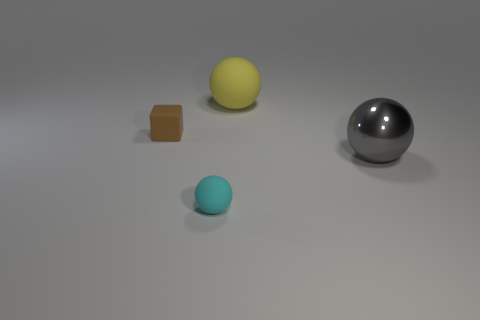There is a cyan ball that is the same size as the brown rubber object; what is it made of?
Your answer should be compact. Rubber. There is a matte object that is in front of the tiny thing left of the tiny rubber ball; what color is it?
Offer a terse response. Cyan. What number of spheres are right of the small rubber ball?
Your answer should be very brief. 2. What is the color of the small matte ball?
Offer a terse response. Cyan. How many small objects are red metallic blocks or brown cubes?
Offer a very short reply. 1. There is a tiny rubber thing in front of the large gray object; is its color the same as the big thing behind the big shiny thing?
Ensure brevity in your answer.  No. What shape is the small rubber thing that is behind the gray thing?
Keep it short and to the point. Cube. Is the number of brown matte blocks less than the number of tiny blue blocks?
Your answer should be compact. No. Are the large sphere behind the tiny brown rubber block and the small cyan ball made of the same material?
Ensure brevity in your answer.  Yes. Are there any brown matte blocks right of the cyan matte sphere?
Your response must be concise. No. 